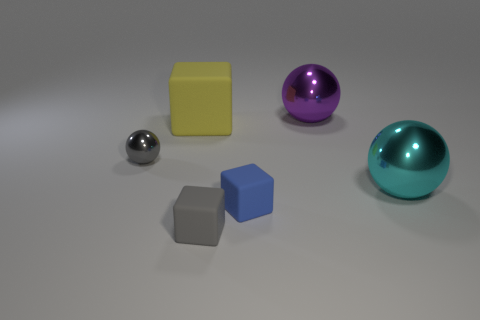Subtract all large balls. How many balls are left? 1 Add 2 tiny gray shiny objects. How many objects exist? 8 Subtract all purple balls. How many balls are left? 2 Subtract 2 cubes. How many cubes are left? 1 Add 3 yellow things. How many yellow things are left? 4 Add 2 tiny gray matte blocks. How many tiny gray matte blocks exist? 3 Subtract 0 purple cylinders. How many objects are left? 6 Subtract all red cubes. Subtract all brown balls. How many cubes are left? 3 Subtract all tiny gray things. Subtract all tiny gray matte blocks. How many objects are left? 3 